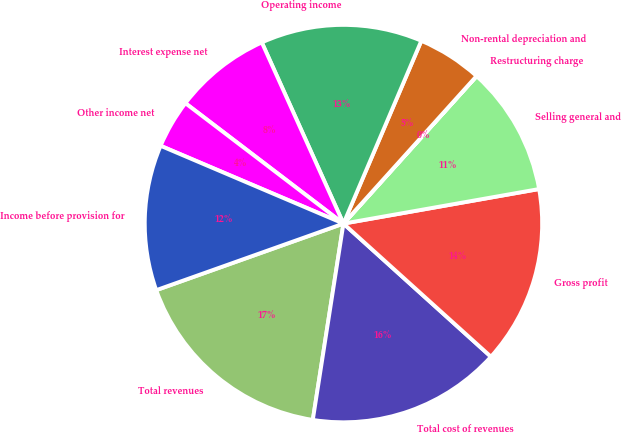<chart> <loc_0><loc_0><loc_500><loc_500><pie_chart><fcel>Total revenues<fcel>Total cost of revenues<fcel>Gross profit<fcel>Selling general and<fcel>Restructuring charge<fcel>Non-rental depreciation and<fcel>Operating income<fcel>Interest expense net<fcel>Other income net<fcel>Income before provision for<nl><fcel>17.1%<fcel>15.78%<fcel>14.47%<fcel>10.53%<fcel>0.01%<fcel>5.27%<fcel>13.15%<fcel>7.9%<fcel>3.96%<fcel>11.84%<nl></chart> 